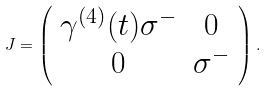Convert formula to latex. <formula><loc_0><loc_0><loc_500><loc_500>J = \left ( \begin{array} { c c } \gamma ^ { ( 4 ) } ( t ) \sigma ^ { - } & 0 \\ 0 & \sigma ^ { - } \end{array} \right ) .</formula> 